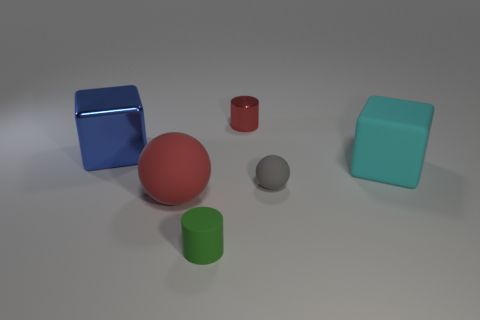Add 4 cyan blocks. How many objects exist? 10 Subtract all cylinders. How many objects are left? 4 Add 4 small green matte spheres. How many small green matte spheres exist? 4 Subtract 1 green cylinders. How many objects are left? 5 Subtract all tiny red objects. Subtract all red cylinders. How many objects are left? 4 Add 5 red rubber things. How many red rubber things are left? 6 